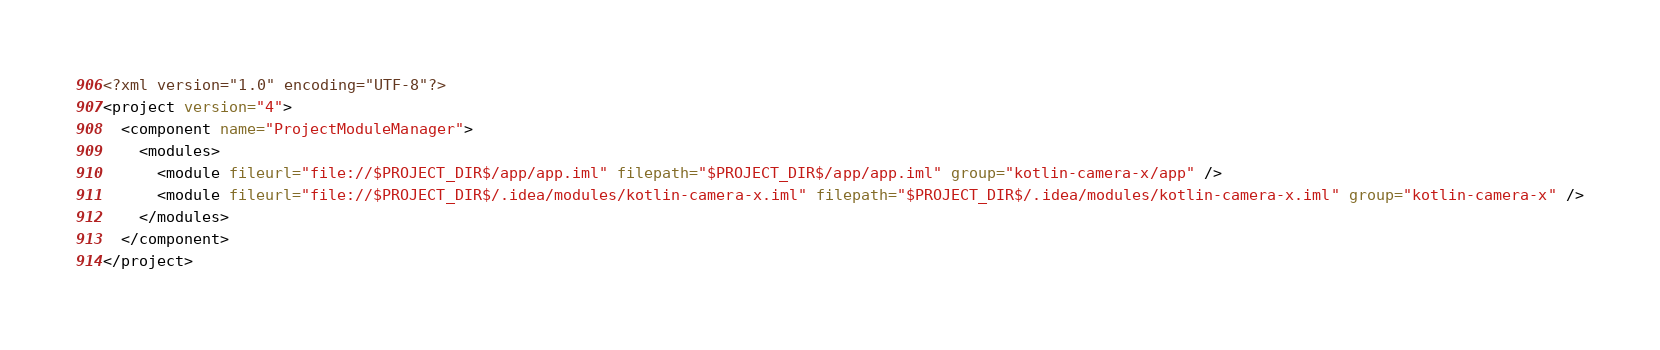Convert code to text. <code><loc_0><loc_0><loc_500><loc_500><_XML_><?xml version="1.0" encoding="UTF-8"?>
<project version="4">
  <component name="ProjectModuleManager">
    <modules>
      <module fileurl="file://$PROJECT_DIR$/app/app.iml" filepath="$PROJECT_DIR$/app/app.iml" group="kotlin-camera-x/app" />
      <module fileurl="file://$PROJECT_DIR$/.idea/modules/kotlin-camera-x.iml" filepath="$PROJECT_DIR$/.idea/modules/kotlin-camera-x.iml" group="kotlin-camera-x" />
    </modules>
  </component>
</project></code> 